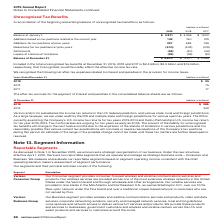According to Verizon Communications's financial document, What was the amount that would favorably affect the effective income tax rate if included in 2019? According to the financial document, $2.4 billion. The relevant text states: "ax benefits at December 31, 2019, 2018 and 2017 is $2.4 billion, $2.3 billion and $1.9 billion, respectively, that if recognized, would favorably affect the effect..." Also, What was the amount that would favorably affect the effective income tax rate if included in 2018? According to the financial document, $2.3 billion. The relevant text states: "December 31, 2019, 2018 and 2017 is $2.4 billion, $2.3 billion and $1.9 billion, respectively, that if recognized, would favorably affect the effective income tax..." Also, What was the amount that would favorably affect the effective income tax rate if included in 2017? According to the financial document, $1.9 billion. The relevant text states: "9, 2018 and 2017 is $2.4 billion, $2.3 billion and $1.9 billion, respectively, that if recognized, would favorably affect the effective income tax rate...." Also, can you calculate: What was the change in the Additions based on tax positions related to the current year from 2018 to 2019? Based on the calculation: 149 - 160, the result is -11 (in millions). This is based on the information: "on tax positions related to the current year 149 160 219 ased on tax positions related to the current year 149 160 219..." The key data points involved are: 149, 160. Also, can you calculate: What was the average Additions for tax positions of prior years for 2017-2019? To answer this question, I need to perform calculations using the financial data. The calculation is: (297 + 699 + 756) / 3, which equals 584 (in millions). This is based on the information: "Additions for tax positions of prior years 297 699 756 dditions for tax positions of prior years 297 699 756 Additions for tax positions of prior years 297 699 756..." The key data points involved are: 297, 699, 756. Also, can you calculate: What was the average settlements for 2017-2019? To answer this question, I need to perform calculations using the financial data. The calculation is: -(58 + 40 + 42) / 3, which equals -46.67 (in millions). This is based on the information: "Settlements (58) (40) (42) Settlements (58) (40) (42) Settlements (58) (40) (42)..." The key data points involved are: 40, 42, 58. 